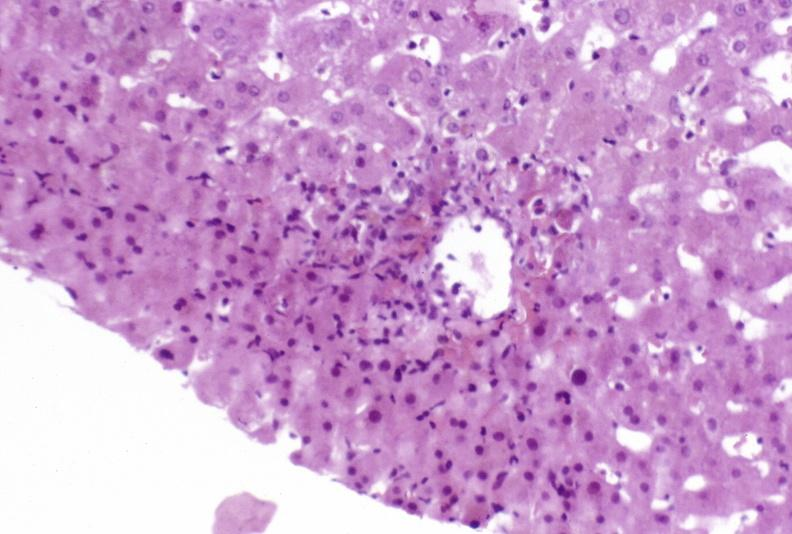what does this image show?
Answer the question using a single word or phrase. Moderate acute rejection 